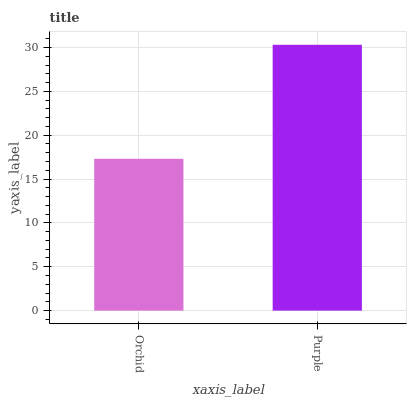Is Orchid the minimum?
Answer yes or no. Yes. Is Purple the maximum?
Answer yes or no. Yes. Is Purple the minimum?
Answer yes or no. No. Is Purple greater than Orchid?
Answer yes or no. Yes. Is Orchid less than Purple?
Answer yes or no. Yes. Is Orchid greater than Purple?
Answer yes or no. No. Is Purple less than Orchid?
Answer yes or no. No. Is Purple the high median?
Answer yes or no. Yes. Is Orchid the low median?
Answer yes or no. Yes. Is Orchid the high median?
Answer yes or no. No. Is Purple the low median?
Answer yes or no. No. 